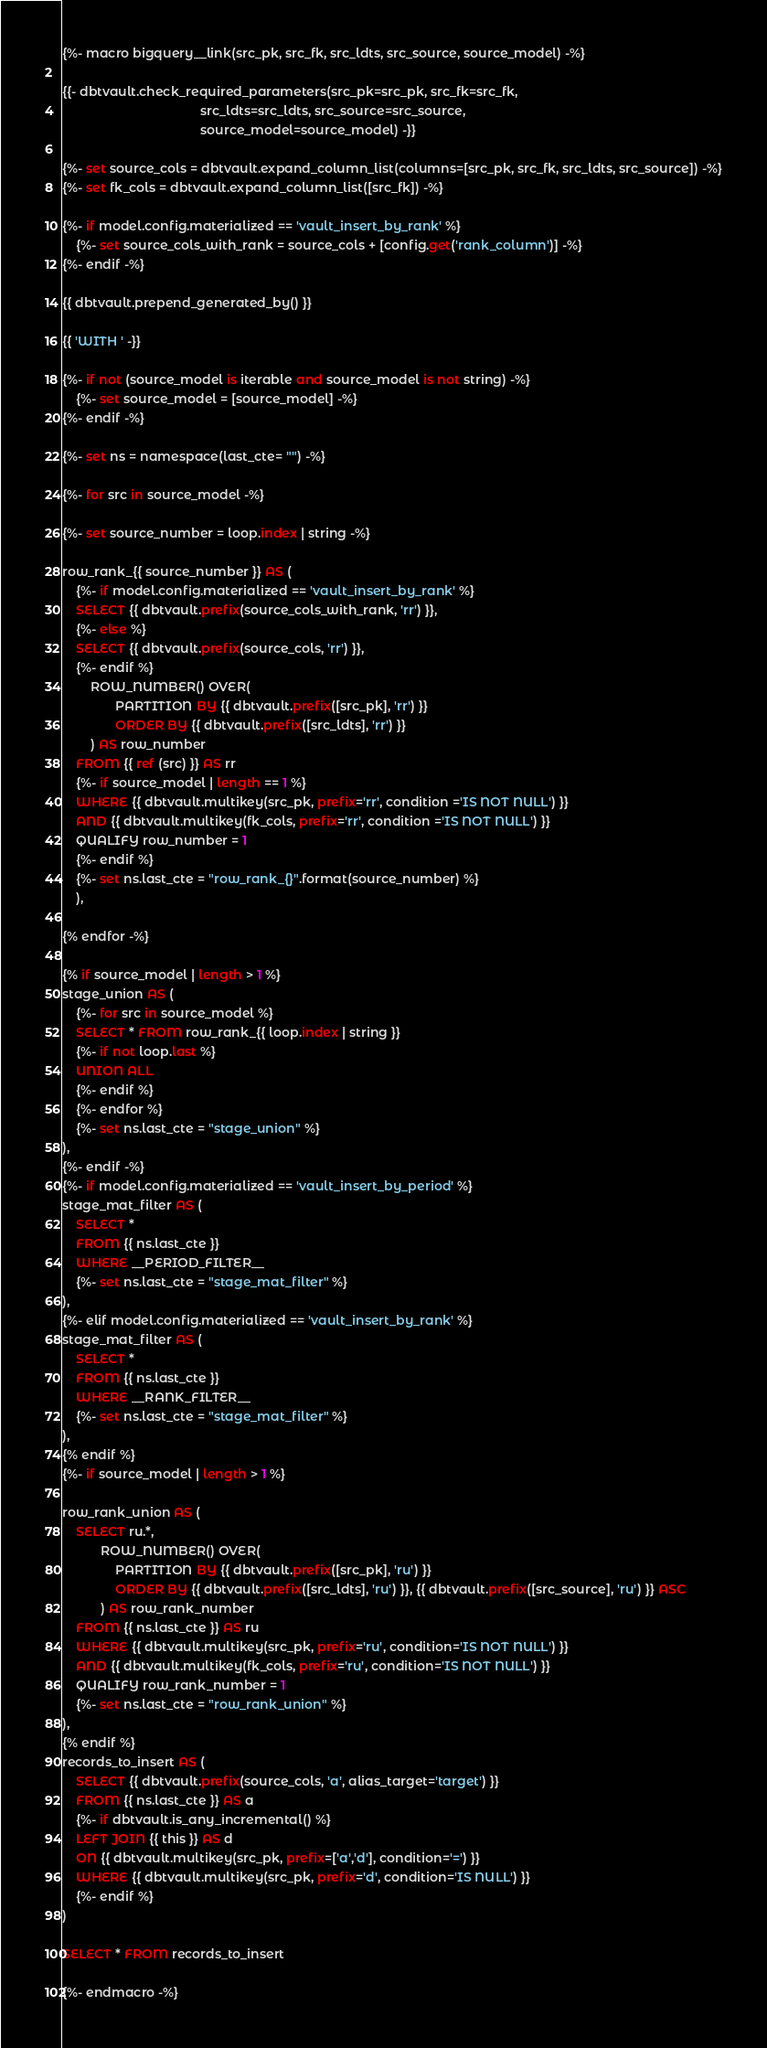<code> <loc_0><loc_0><loc_500><loc_500><_SQL_>{%- macro bigquery__link(src_pk, src_fk, src_ldts, src_source, source_model) -%}

{{- dbtvault.check_required_parameters(src_pk=src_pk, src_fk=src_fk,
                                       src_ldts=src_ldts, src_source=src_source,
                                       source_model=source_model) -}}

{%- set source_cols = dbtvault.expand_column_list(columns=[src_pk, src_fk, src_ldts, src_source]) -%}
{%- set fk_cols = dbtvault.expand_column_list([src_fk]) -%}

{%- if model.config.materialized == 'vault_insert_by_rank' %}
    {%- set source_cols_with_rank = source_cols + [config.get('rank_column')] -%}
{%- endif -%}

{{ dbtvault.prepend_generated_by() }}

{{ 'WITH ' -}}

{%- if not (source_model is iterable and source_model is not string) -%}
    {%- set source_model = [source_model] -%}
{%- endif -%}

{%- set ns = namespace(last_cte= "") -%}

{%- for src in source_model -%}

{%- set source_number = loop.index | string -%}

row_rank_{{ source_number }} AS (
    {%- if model.config.materialized == 'vault_insert_by_rank' %}
    SELECT {{ dbtvault.prefix(source_cols_with_rank, 'rr') }},
    {%- else %}
    SELECT {{ dbtvault.prefix(source_cols, 'rr') }},
    {%- endif %}
        ROW_NUMBER() OVER(
               PARTITION BY {{ dbtvault.prefix([src_pk], 'rr') }}
               ORDER BY {{ dbtvault.prefix([src_ldts], 'rr') }}
        ) AS row_number
    FROM {{ ref (src) }} AS rr
    {%- if source_model | length == 1 %}
    WHERE {{ dbtvault.multikey(src_pk, prefix='rr', condition ='IS NOT NULL') }}
    AND {{ dbtvault.multikey(fk_cols, prefix='rr', condition ='IS NOT NULL') }}
    QUALIFY row_number = 1
    {%- endif %}
    {%- set ns.last_cte = "row_rank_{}".format(source_number) %}
    ),

{% endfor -%}

{% if source_model | length > 1 %}
stage_union AS (
    {%- for src in source_model %}
    SELECT * FROM row_rank_{{ loop.index | string }}
    {%- if not loop.last %}
    UNION ALL
    {%- endif %}
    {%- endfor %}
    {%- set ns.last_cte = "stage_union" %}
),
{%- endif -%}
{%- if model.config.materialized == 'vault_insert_by_period' %}
stage_mat_filter AS (
    SELECT *
    FROM {{ ns.last_cte }}
    WHERE __PERIOD_FILTER__
    {%- set ns.last_cte = "stage_mat_filter" %}
),
{%- elif model.config.materialized == 'vault_insert_by_rank' %}
stage_mat_filter AS (
    SELECT *
    FROM {{ ns.last_cte }}
    WHERE __RANK_FILTER__
    {%- set ns.last_cte = "stage_mat_filter" %}
),
{% endif %}
{%- if source_model | length > 1 %}

row_rank_union AS (
    SELECT ru.*,
           ROW_NUMBER() OVER(
               PARTITION BY {{ dbtvault.prefix([src_pk], 'ru') }}
               ORDER BY {{ dbtvault.prefix([src_ldts], 'ru') }}, {{ dbtvault.prefix([src_source], 'ru') }} ASC
           ) AS row_rank_number
    FROM {{ ns.last_cte }} AS ru
    WHERE {{ dbtvault.multikey(src_pk, prefix='ru', condition='IS NOT NULL') }}
    AND {{ dbtvault.multikey(fk_cols, prefix='ru', condition='IS NOT NULL') }}
    QUALIFY row_rank_number = 1
    {%- set ns.last_cte = "row_rank_union" %}
),
{% endif %}
records_to_insert AS (
    SELECT {{ dbtvault.prefix(source_cols, 'a', alias_target='target') }}
    FROM {{ ns.last_cte }} AS a
    {%- if dbtvault.is_any_incremental() %}
    LEFT JOIN {{ this }} AS d
    ON {{ dbtvault.multikey(src_pk, prefix=['a','d'], condition='=') }}
    WHERE {{ dbtvault.multikey(src_pk, prefix='d', condition='IS NULL') }}
    {%- endif %}
)

SELECT * FROM records_to_insert

{%- endmacro -%}</code> 